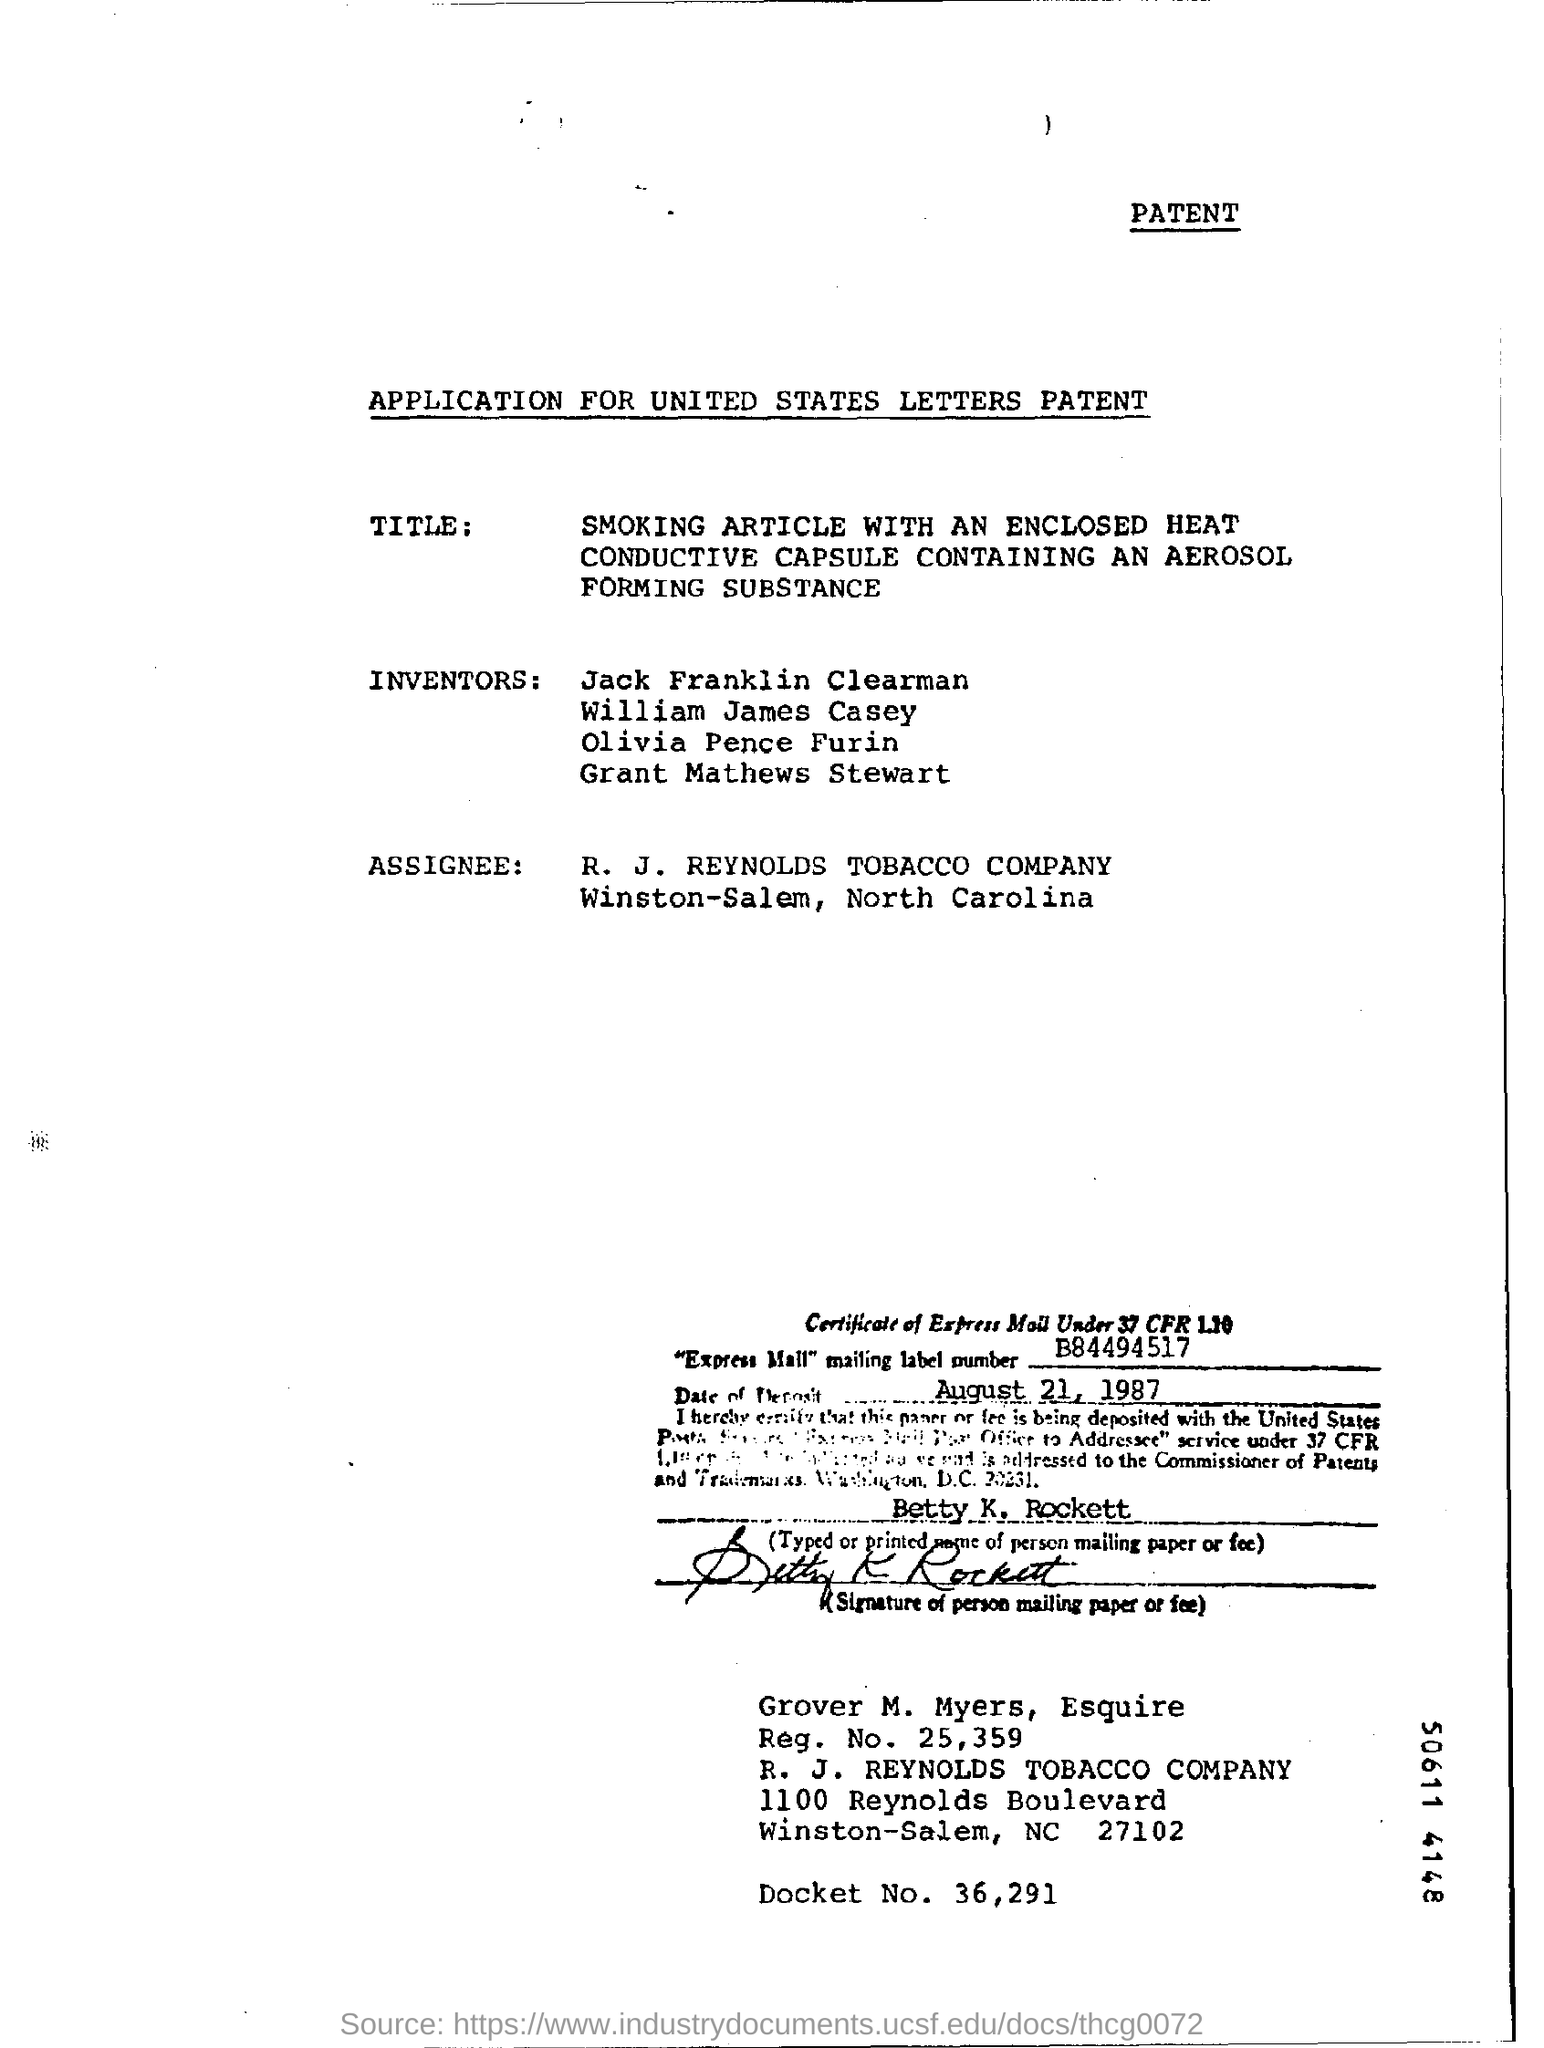Give some essential details in this illustration. The registration number is 25,359. The mailing label number is B84494517... The date mentioned in the document is August 21, 1987. The R. J. Reynolds Tobacco Company is a company name. The docket number is 36,291. 